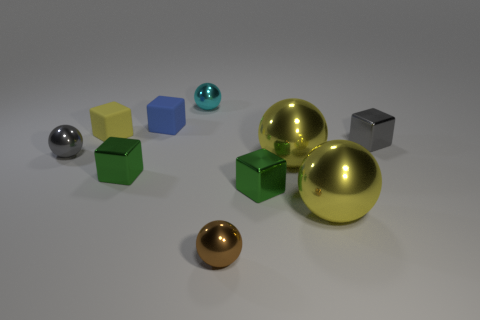Is the tiny cyan sphere made of the same material as the tiny gray object that is left of the cyan shiny sphere?
Offer a terse response. Yes. What number of objects are either big blue cubes or small green things?
Ensure brevity in your answer.  2. Do the green cube to the left of the cyan thing and the matte object that is in front of the small blue object have the same size?
Provide a short and direct response. Yes. How many cylinders are rubber objects or yellow matte objects?
Your answer should be compact. 0. Is there a yellow metal cylinder?
Your response must be concise. No. Are there any other things that are the same shape as the tiny cyan object?
Make the answer very short. Yes. What number of things are small green cubes that are left of the small cyan object or tiny purple blocks?
Your response must be concise. 1. There is a green shiny thing that is left of the small green shiny object to the right of the small cyan metal object; what number of big metallic objects are behind it?
Offer a very short reply. 1. Are there any other things that have the same size as the gray shiny ball?
Offer a terse response. Yes. What is the shape of the yellow metallic object that is behind the green block on the right side of the small metallic sphere that is behind the gray metallic block?
Your answer should be very brief. Sphere. 